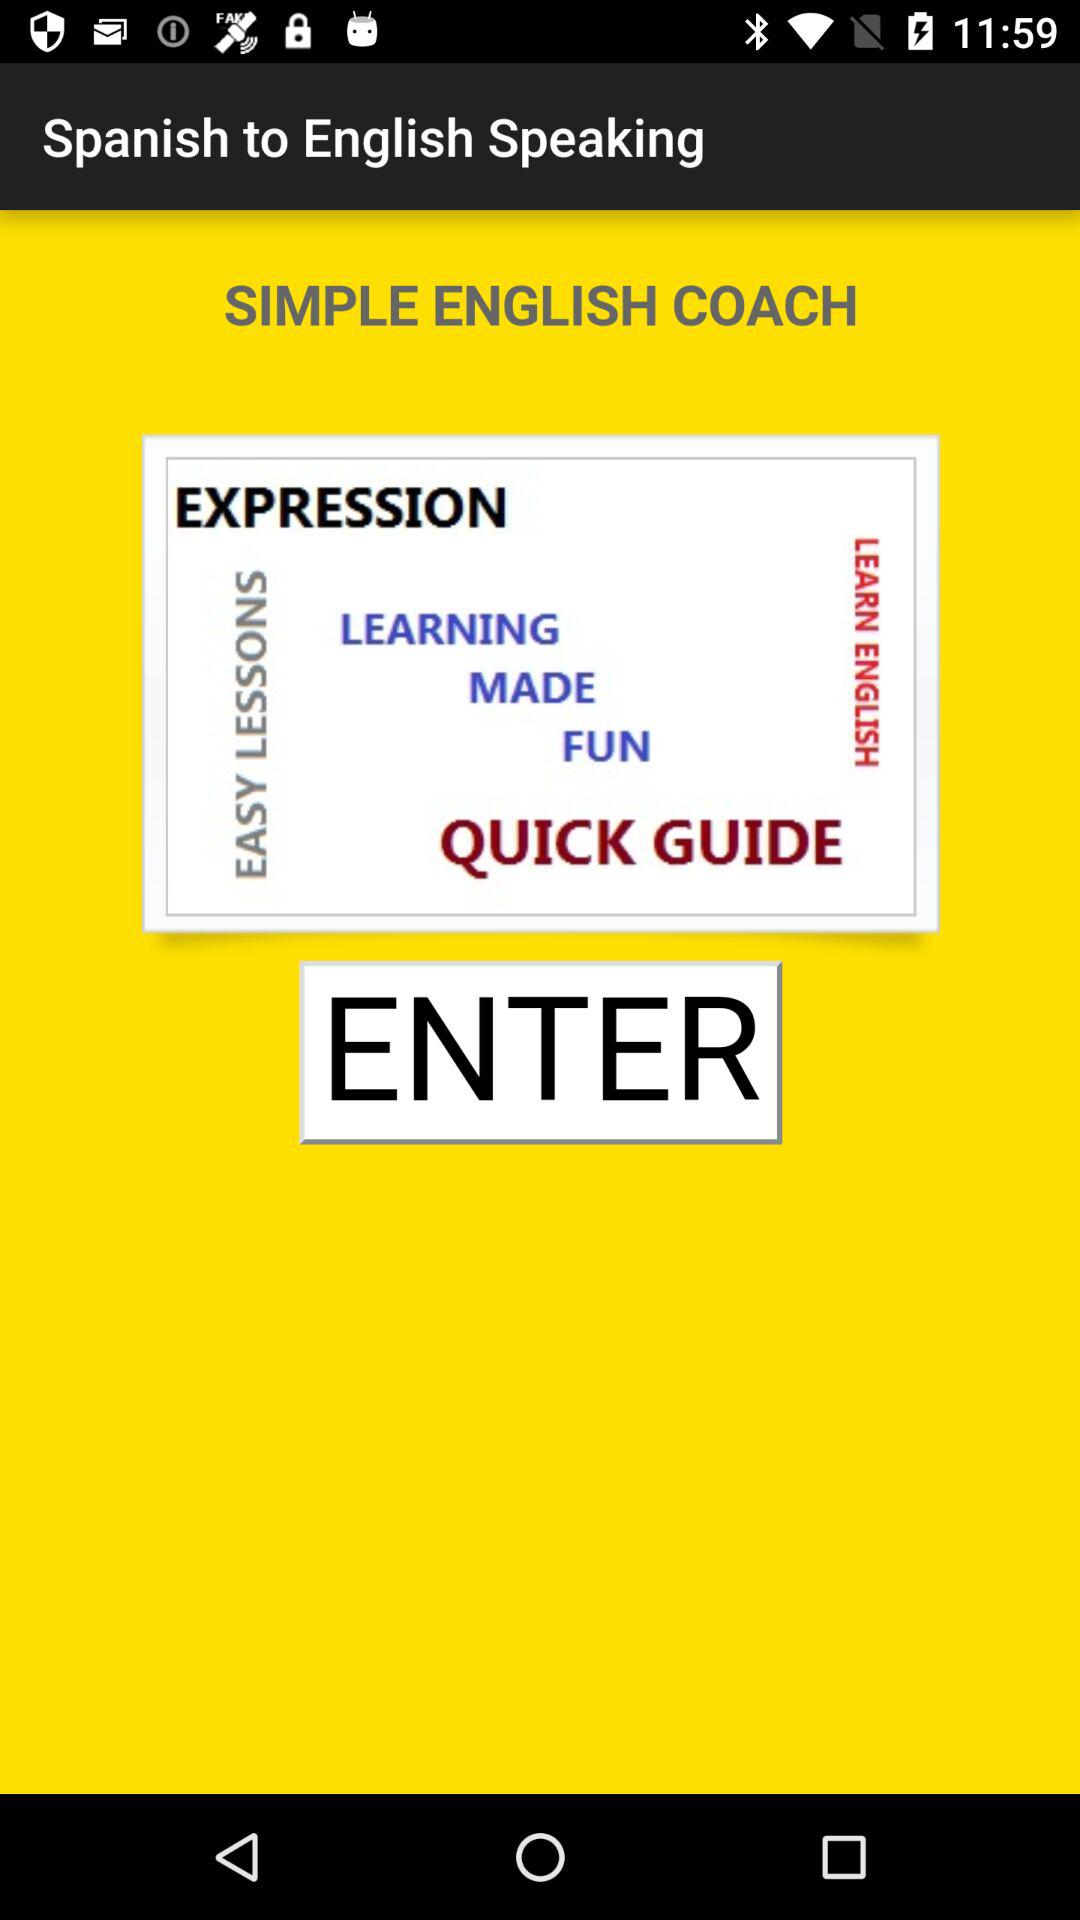What language is translated into English? The paired language is Spanish. 